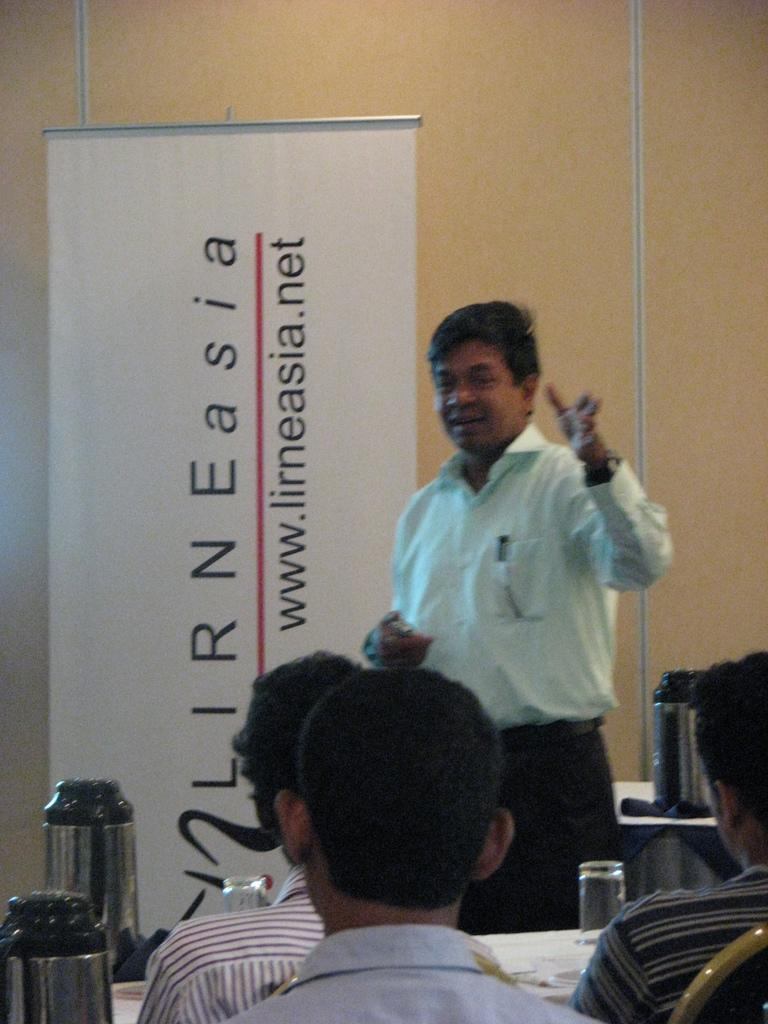Provide a one-sentence caption for the provided image. A man speaks to a group near a sign that says www.lirneasia.net. 